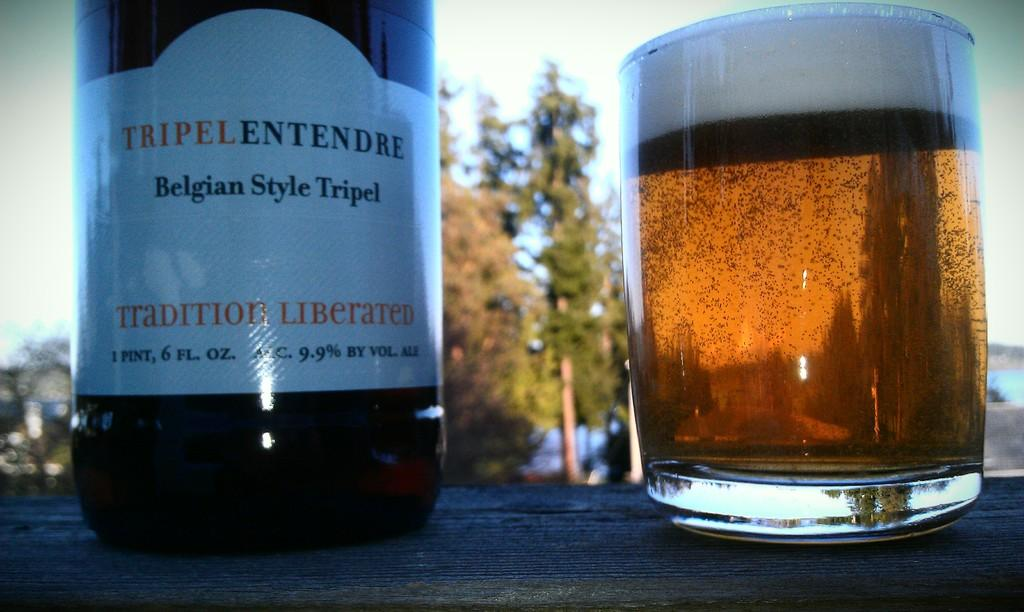<image>
Present a compact description of the photo's key features. a glass and bottle of Tripel Belgian Style 